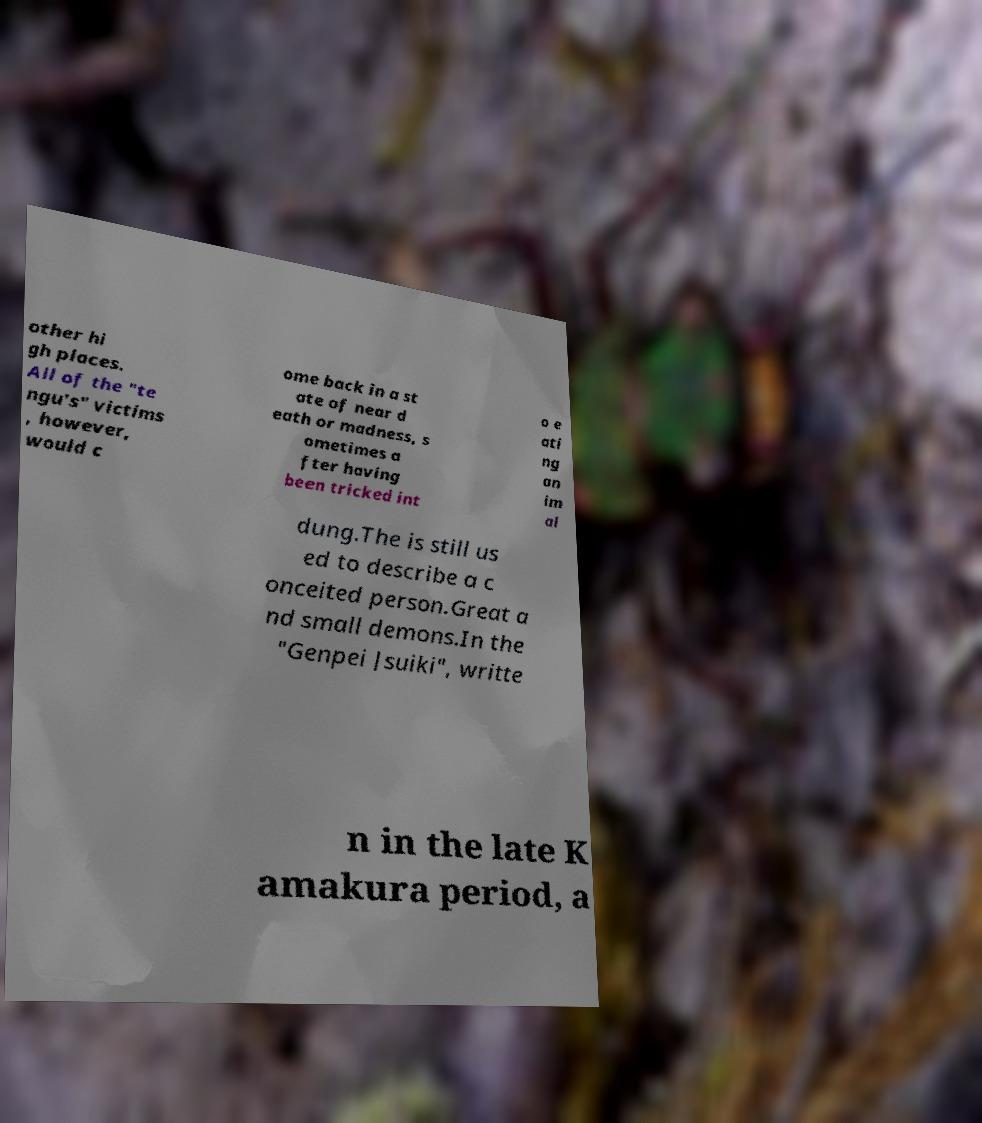Can you accurately transcribe the text from the provided image for me? other hi gh places. All of the "te ngu's" victims , however, would c ome back in a st ate of near d eath or madness, s ometimes a fter having been tricked int o e ati ng an im al dung.The is still us ed to describe a c onceited person.Great a nd small demons.In the "Genpei Jsuiki", writte n in the late K amakura period, a 